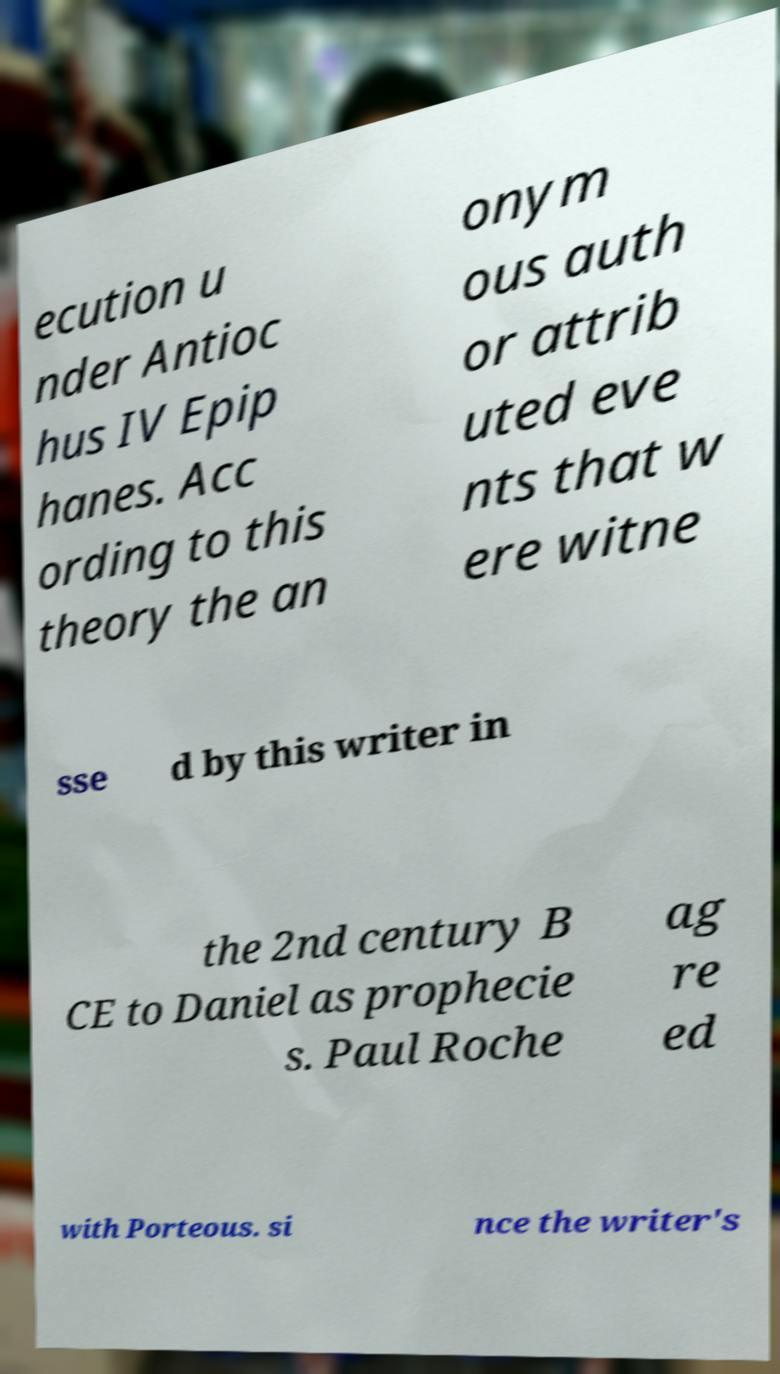What messages or text are displayed in this image? I need them in a readable, typed format. ecution u nder Antioc hus IV Epip hanes. Acc ording to this theory the an onym ous auth or attrib uted eve nts that w ere witne sse d by this writer in the 2nd century B CE to Daniel as prophecie s. Paul Roche ag re ed with Porteous. si nce the writer's 